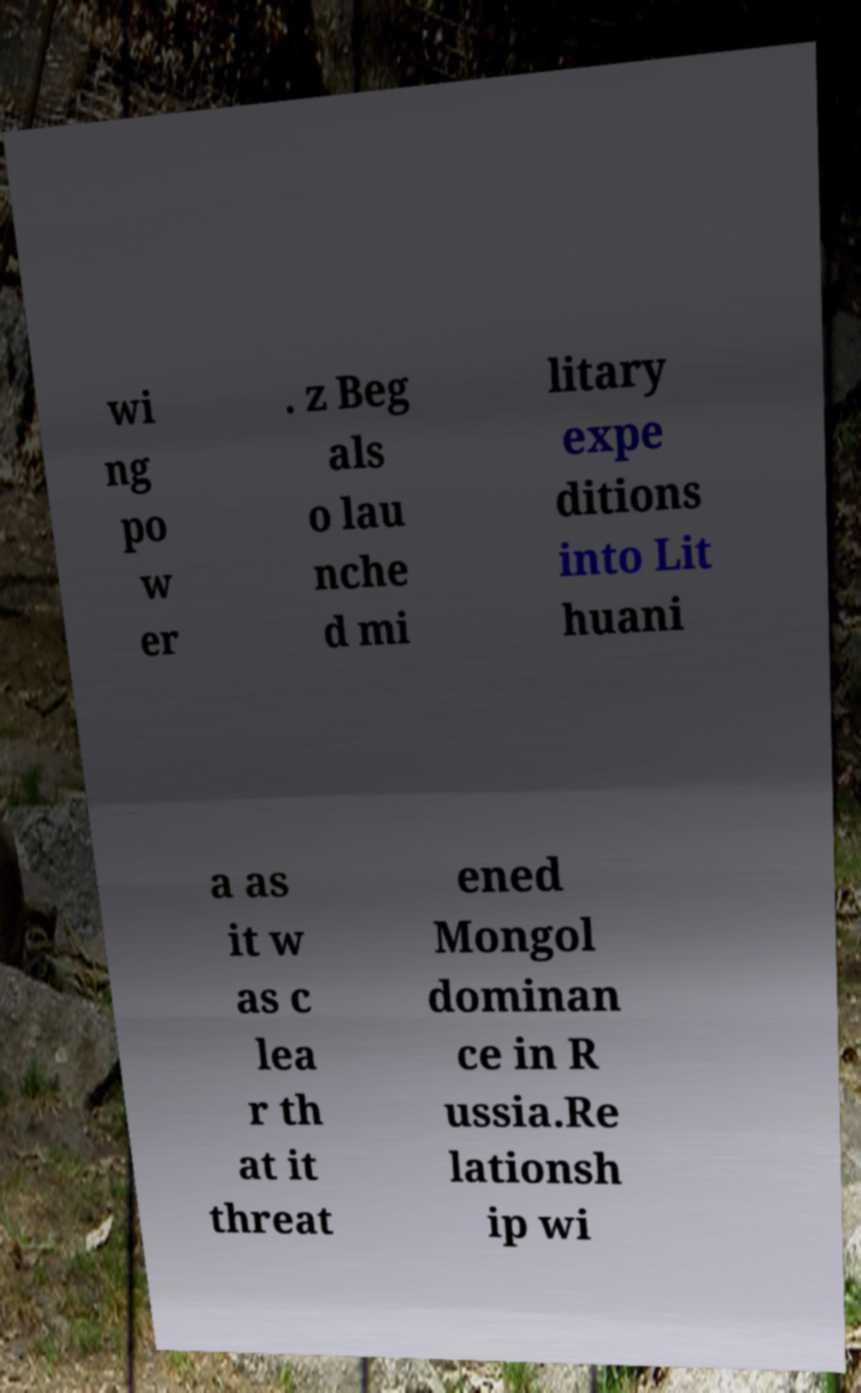Could you assist in decoding the text presented in this image and type it out clearly? wi ng po w er . z Beg als o lau nche d mi litary expe ditions into Lit huani a as it w as c lea r th at it threat ened Mongol dominan ce in R ussia.Re lationsh ip wi 